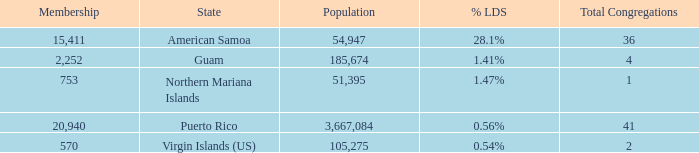What is Population, when Total Congregations is less than 4, and when % LDS is 0.54%? 105275.0. 